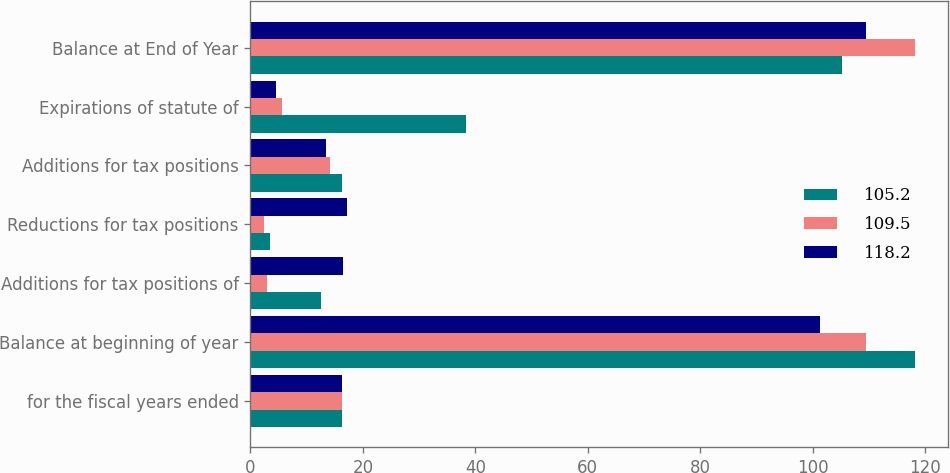<chart> <loc_0><loc_0><loc_500><loc_500><stacked_bar_chart><ecel><fcel>for the fiscal years ended<fcel>Balance at beginning of year<fcel>Additions for tax positions of<fcel>Reductions for tax positions<fcel>Additions for tax positions<fcel>Expirations of statute of<fcel>Balance at End of Year<nl><fcel>105.2<fcel>16.35<fcel>118.2<fcel>12.6<fcel>3.4<fcel>16.2<fcel>38.3<fcel>105.2<nl><fcel>109.5<fcel>16.35<fcel>109.5<fcel>3<fcel>2.4<fcel>14.1<fcel>5.7<fcel>118.2<nl><fcel>118.2<fcel>16.35<fcel>101.3<fcel>16.5<fcel>17.1<fcel>13.4<fcel>4.6<fcel>109.5<nl></chart> 